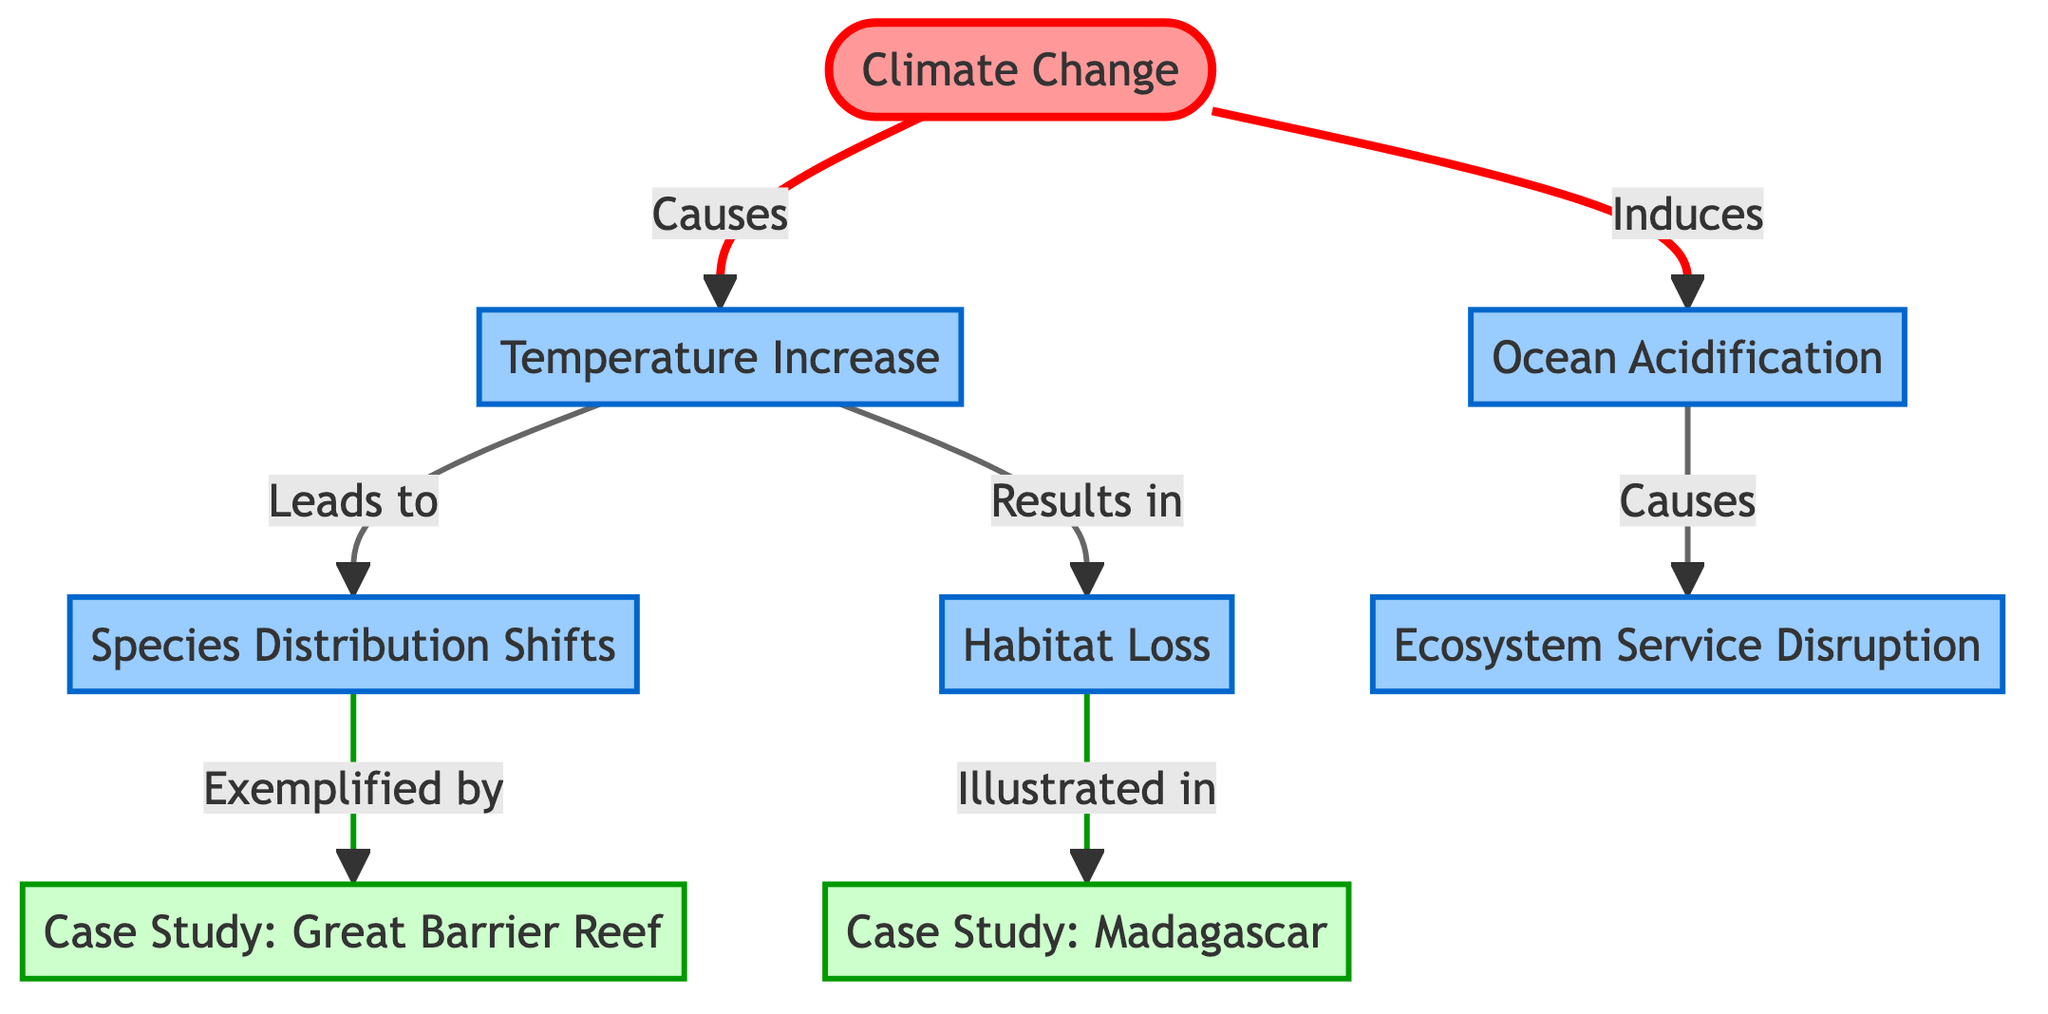What are the two major effects of climate change depicted in the diagram? The diagram lists the effects of climate change, showing "Temperature Increase" and "Ocean Acidification" as two distinct branches originating from "Climate Change."
Answer: Temperature Increase, Ocean Acidification How many nodes are present in the diagram? The diagram contains a total of eight nodes, counting each unique concept or case study.
Answer: 8 Which case study is linked to species distribution shifts? By examining the diagram, it is clear that the case study linked to "Species Distribution Shifts" is the "Case Study: Great Barrier Reef."
Answer: Case Study: Great Barrier Reef What effect is linked to habitat loss according to the diagram? The diagram indicates that "Habitat Loss" leads to the "Case Study: Madagascar," suggesting a direct relationship between these two elements.
Answer: Case Study: Madagascar What is the relationship between ocean acidification and ecosystem service disruption? The diagram shows that "Ocean Acidification" is a causal factor for "Ecosystem Service Disruption," establishing a direct influence between these two nodes.
Answer: Causes How many edges are directed from "Temperature Increase"? The diagram depicts "Temperature Increase" connecting to two edges: one to "Species Distribution Shifts" and another to "Habitat Loss." Thus, it has two directed edges.
Answer: 2 Which node directly results from climate change by way of temperature increase? The flow from "Climate Change" to "Temperature Increase" leads to "Species Distribution Shifts" as a direct result of temperature increase.
Answer: Species Distribution Shifts What do the arrows in the diagram signify? The arrows in the diagram represent directional relationships, indicating how one node affects or contributes to another in the context of climate change and biodiversity impacts.
Answer: Causal relationships 